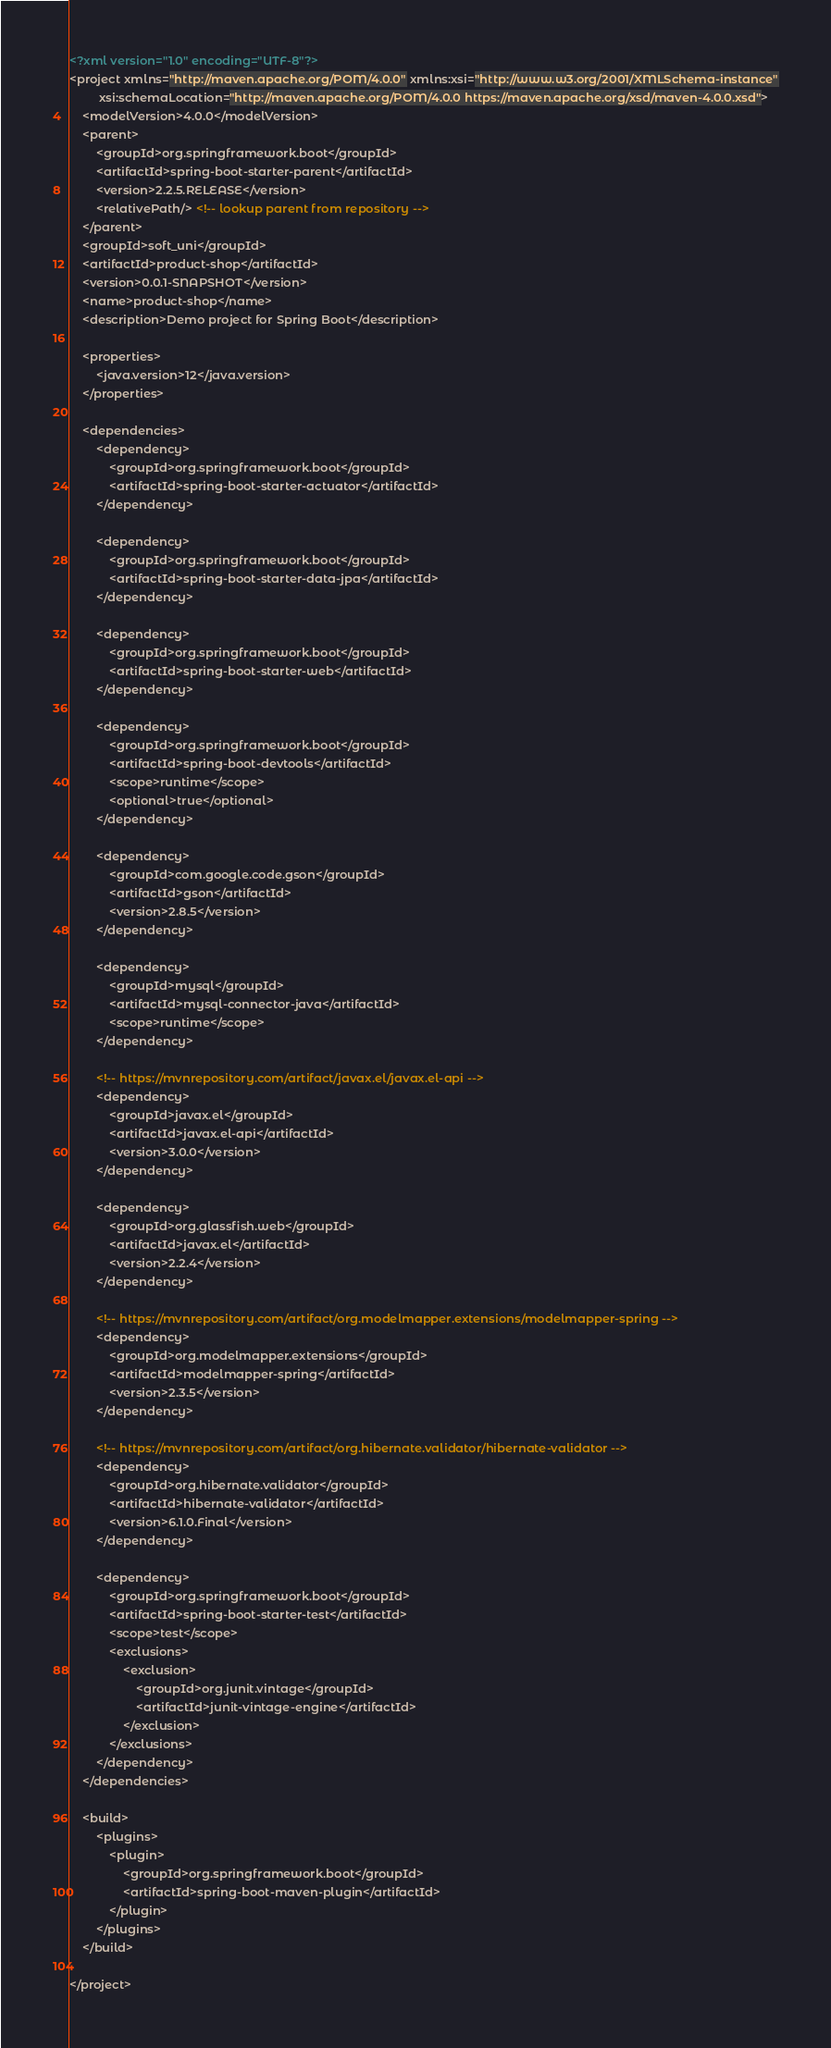<code> <loc_0><loc_0><loc_500><loc_500><_XML_><?xml version="1.0" encoding="UTF-8"?>
<project xmlns="http://maven.apache.org/POM/4.0.0" xmlns:xsi="http://www.w3.org/2001/XMLSchema-instance"
         xsi:schemaLocation="http://maven.apache.org/POM/4.0.0 https://maven.apache.org/xsd/maven-4.0.0.xsd">
    <modelVersion>4.0.0</modelVersion>
    <parent>
        <groupId>org.springframework.boot</groupId>
        <artifactId>spring-boot-starter-parent</artifactId>
        <version>2.2.5.RELEASE</version>
        <relativePath/> <!-- lookup parent from repository -->
    </parent>
    <groupId>soft_uni</groupId>
    <artifactId>product-shop</artifactId>
    <version>0.0.1-SNAPSHOT</version>
    <name>product-shop</name>
    <description>Demo project for Spring Boot</description>

    <properties>
        <java.version>12</java.version>
    </properties>

    <dependencies>
        <dependency>
            <groupId>org.springframework.boot</groupId>
            <artifactId>spring-boot-starter-actuator</artifactId>
        </dependency>

        <dependency>
            <groupId>org.springframework.boot</groupId>
            <artifactId>spring-boot-starter-data-jpa</artifactId>
        </dependency>

        <dependency>
            <groupId>org.springframework.boot</groupId>
            <artifactId>spring-boot-starter-web</artifactId>
        </dependency>

        <dependency>
            <groupId>org.springframework.boot</groupId>
            <artifactId>spring-boot-devtools</artifactId>
            <scope>runtime</scope>
            <optional>true</optional>
        </dependency>

        <dependency>
            <groupId>com.google.code.gson</groupId>
            <artifactId>gson</artifactId>
            <version>2.8.5</version>
        </dependency>

        <dependency>
            <groupId>mysql</groupId>
            <artifactId>mysql-connector-java</artifactId>
            <scope>runtime</scope>
        </dependency>

        <!-- https://mvnrepository.com/artifact/javax.el/javax.el-api -->
        <dependency>
            <groupId>javax.el</groupId>
            <artifactId>javax.el-api</artifactId>
            <version>3.0.0</version>
        </dependency>

        <dependency>
            <groupId>org.glassfish.web</groupId>
            <artifactId>javax.el</artifactId>
            <version>2.2.4</version>
        </dependency>

        <!-- https://mvnrepository.com/artifact/org.modelmapper.extensions/modelmapper-spring -->
        <dependency>
            <groupId>org.modelmapper.extensions</groupId>
            <artifactId>modelmapper-spring</artifactId>
            <version>2.3.5</version>
        </dependency>

        <!-- https://mvnrepository.com/artifact/org.hibernate.validator/hibernate-validator -->
        <dependency>
            <groupId>org.hibernate.validator</groupId>
            <artifactId>hibernate-validator</artifactId>
            <version>6.1.0.Final</version>
        </dependency>

        <dependency>
            <groupId>org.springframework.boot</groupId>
            <artifactId>spring-boot-starter-test</artifactId>
            <scope>test</scope>
            <exclusions>
                <exclusion>
                    <groupId>org.junit.vintage</groupId>
                    <artifactId>junit-vintage-engine</artifactId>
                </exclusion>
            </exclusions>
        </dependency>
    </dependencies>

    <build>
        <plugins>
            <plugin>
                <groupId>org.springframework.boot</groupId>
                <artifactId>spring-boot-maven-plugin</artifactId>
            </plugin>
        </plugins>
    </build>

</project>
</code> 